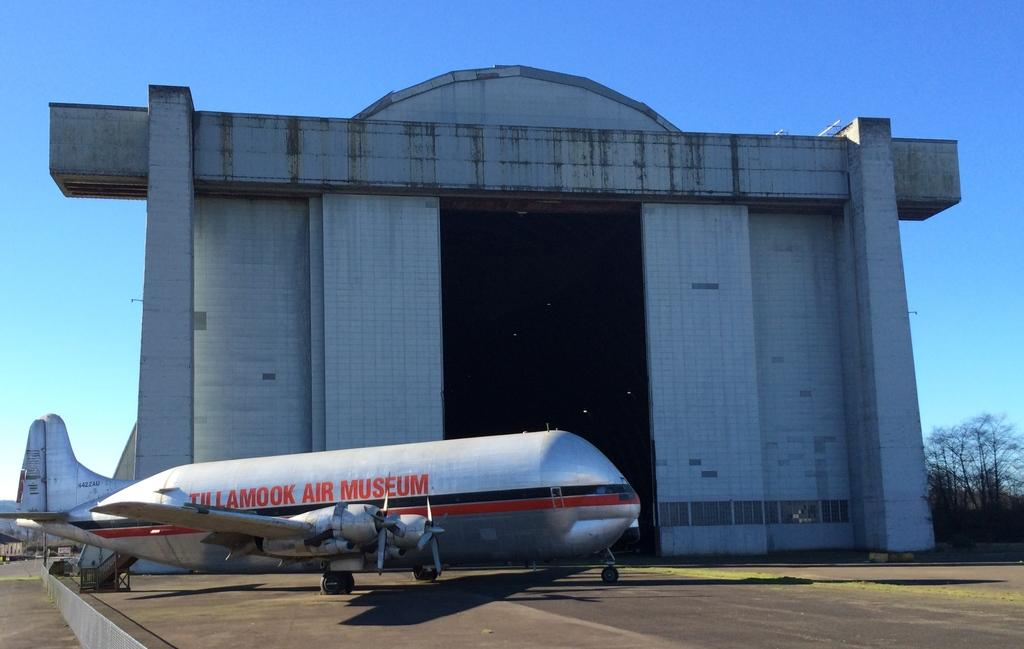What is the main subject of the image? The main subject of the image is an airplane on the ground. What else can be seen in the image besides the airplane? There is a building and trees on the right side of the image. What is visible in the background of the image? The sky is visible in the background of the image. Can you see the force of the river in the image? There is no river present in the image, so it is not possible to see the force of a river. 